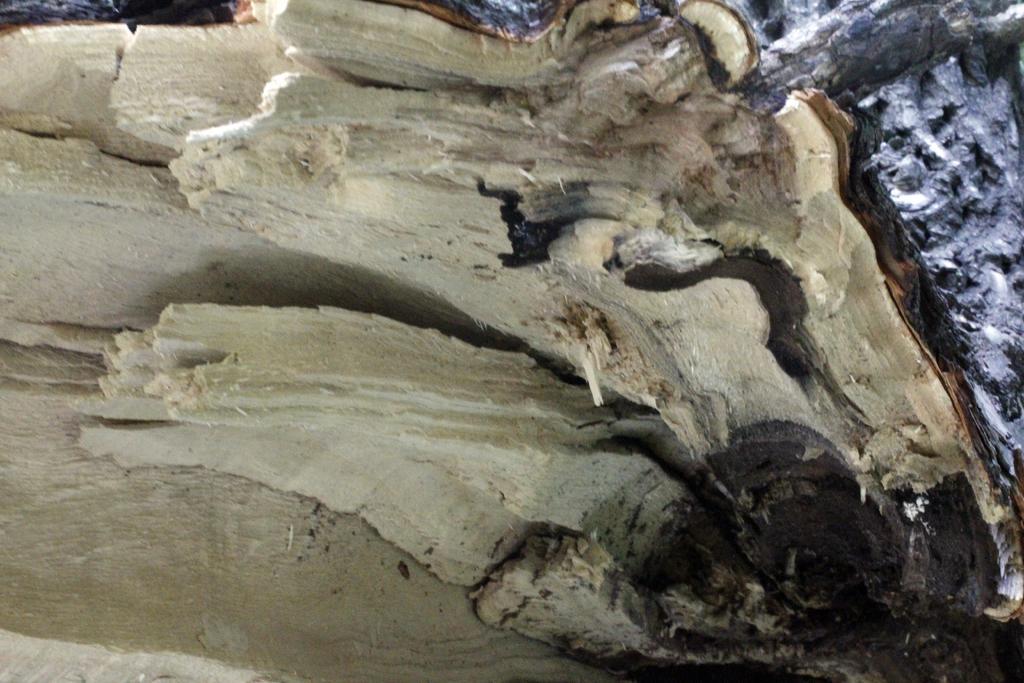Describe this image in one or two sentences. In this image in the center it looks like a truncated tree, and in the background there are trees. 